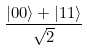<formula> <loc_0><loc_0><loc_500><loc_500>\frac { | 0 0 \rangle + | 1 1 \rangle } { \sqrt { 2 } }</formula> 